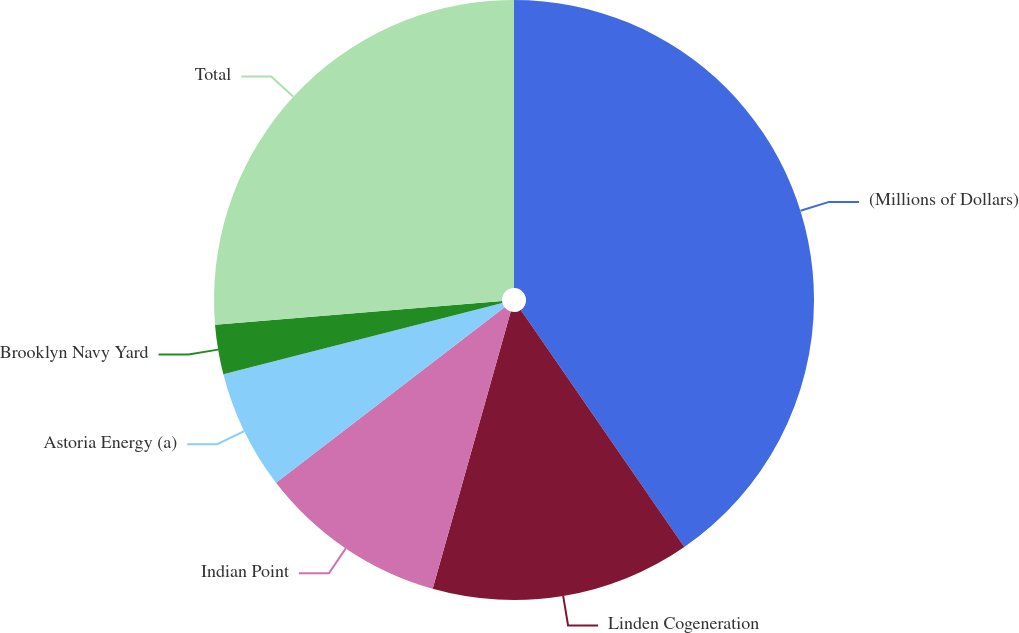<chart> <loc_0><loc_0><loc_500><loc_500><pie_chart><fcel>(Millions of Dollars)<fcel>Linden Cogeneration<fcel>Indian Point<fcel>Astoria Energy (a)<fcel>Brooklyn Navy Yard<fcel>Total<nl><fcel>40.39%<fcel>13.98%<fcel>10.21%<fcel>6.44%<fcel>2.67%<fcel>26.31%<nl></chart> 